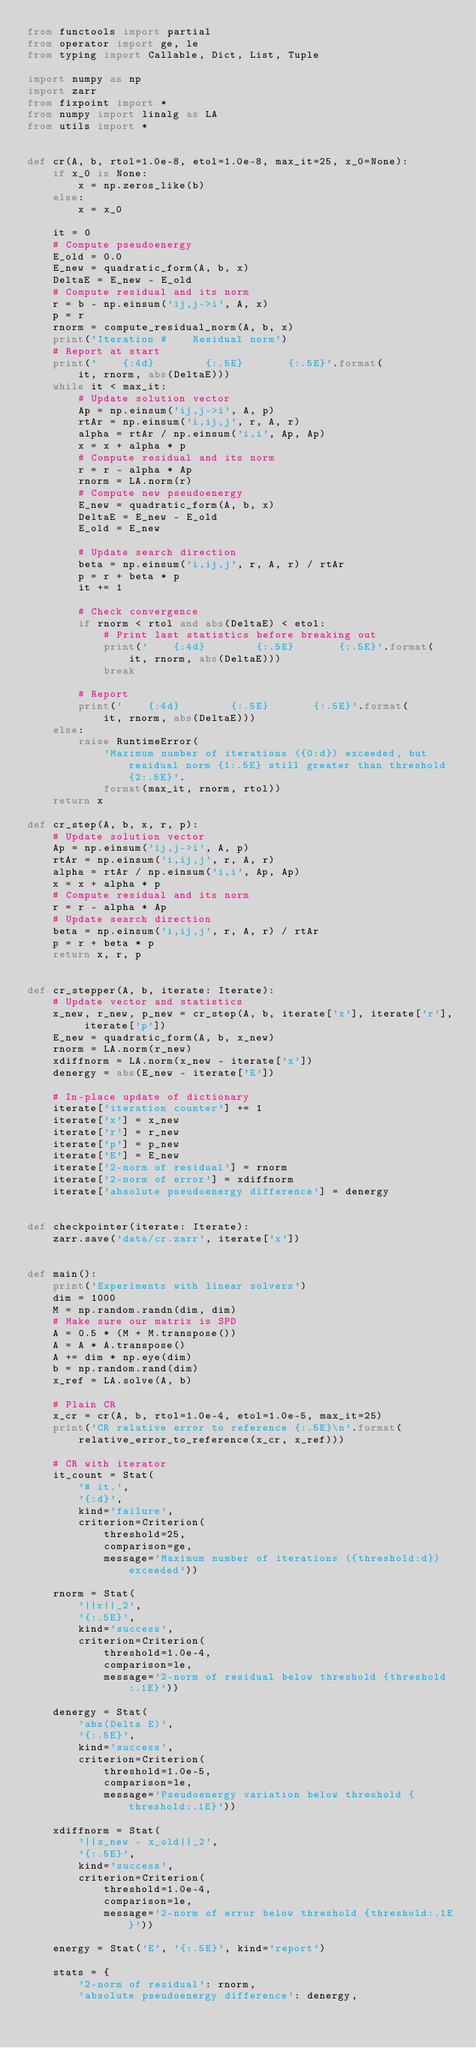<code> <loc_0><loc_0><loc_500><loc_500><_Python_>from functools import partial
from operator import ge, le
from typing import Callable, Dict, List, Tuple

import numpy as np
import zarr
from fixpoint import *
from numpy import linalg as LA
from utils import *


def cr(A, b, rtol=1.0e-8, etol=1.0e-8, max_it=25, x_0=None):
    if x_0 is None:
        x = np.zeros_like(b)
    else:
        x = x_0

    it = 0
    # Compute pseudoenergy
    E_old = 0.0
    E_new = quadratic_form(A, b, x)
    DeltaE = E_new - E_old
    # Compute residual and its norm
    r = b - np.einsum('ij,j->i', A, x)
    p = r
    rnorm = compute_residual_norm(A, b, x)
    print('Iteration #    Residual norm')
    # Report at start
    print('    {:4d}        {:.5E}       {:.5E}'.format(
        it, rnorm, abs(DeltaE)))
    while it < max_it:
        # Update solution vector
        Ap = np.einsum('ij,j->i', A, p)
        rtAr = np.einsum('i,ij,j', r, A, r)
        alpha = rtAr / np.einsum('i,i', Ap, Ap)
        x = x + alpha * p
        # Compute residual and its norm
        r = r - alpha * Ap
        rnorm = LA.norm(r)
        # Compute new pseudoenergy
        E_new = quadratic_form(A, b, x)
        DeltaE = E_new - E_old
        E_old = E_new

        # Update search direction
        beta = np.einsum('i,ij,j', r, A, r) / rtAr
        p = r + beta * p
        it += 1

        # Check convergence
        if rnorm < rtol and abs(DeltaE) < etol:
            # Print last statistics before breaking out
            print('    {:4d}        {:.5E}       {:.5E}'.format(
                it, rnorm, abs(DeltaE)))
            break

        # Report
        print('    {:4d}        {:.5E}       {:.5E}'.format(
            it, rnorm, abs(DeltaE)))
    else:
        raise RuntimeError(
            'Maximum number of iterations ({0:d}) exceeded, but residual norm {1:.5E} still greater than threshold {2:.5E}'.
            format(max_it, rnorm, rtol))
    return x

def cr_step(A, b, x, r, p):
    # Update solution vector
    Ap = np.einsum('ij,j->i', A, p)
    rtAr = np.einsum('i,ij,j', r, A, r)
    alpha = rtAr / np.einsum('i,i', Ap, Ap)
    x = x + alpha * p
    # Compute residual and its norm
    r = r - alpha * Ap
    # Update search direction
    beta = np.einsum('i,ij,j', r, A, r) / rtAr
    p = r + beta * p
    return x, r, p


def cr_stepper(A, b, iterate: Iterate):
    # Update vector and statistics
    x_new, r_new, p_new = cr_step(A, b, iterate['x'], iterate['r'], iterate['p'])
    E_new = quadratic_form(A, b, x_new)
    rnorm = LA.norm(r_new)
    xdiffnorm = LA.norm(x_new - iterate['x'])
    denergy = abs(E_new - iterate['E'])

    # In-place update of dictionary
    iterate['iteration counter'] += 1
    iterate['x'] = x_new
    iterate['r'] = r_new
    iterate['p'] = p_new
    iterate['E'] = E_new
    iterate['2-norm of residual'] = rnorm
    iterate['2-norm of error'] = xdiffnorm
    iterate['absolute pseudoenergy difference'] = denergy


def checkpointer(iterate: Iterate):
    zarr.save('data/cr.zarr', iterate['x'])


def main():
    print('Experiments with linear solvers')
    dim = 1000
    M = np.random.randn(dim, dim)
    # Make sure our matrix is SPD
    A = 0.5 * (M + M.transpose())
    A = A * A.transpose()
    A += dim * np.eye(dim)
    b = np.random.rand(dim)
    x_ref = LA.solve(A, b)

    # Plain CR
    x_cr = cr(A, b, rtol=1.0e-4, etol=1.0e-5, max_it=25)
    print('CR relative error to reference {:.5E}\n'.format(
        relative_error_to_reference(x_cr, x_ref)))

    # CR with iterator
    it_count = Stat(
        '# it.',
        '{:d}',
        kind='failure',
        criterion=Criterion(
            threshold=25,
            comparison=ge,
            message='Maximum number of iterations ({threshold:d}) exceeded'))

    rnorm = Stat(
        '||r||_2',
        '{:.5E}',
        kind='success',
        criterion=Criterion(
            threshold=1.0e-4,
            comparison=le,
            message='2-norm of residual below threshold {threshold:.1E}'))

    denergy = Stat(
        'abs(Delta E)',
        '{:.5E}',
        kind='success',
        criterion=Criterion(
            threshold=1.0e-5,
            comparison=le,
            message='Pseudoenergy variation below threshold {threshold:.1E}'))

    xdiffnorm = Stat(
        '||x_new - x_old||_2',
        '{:.5E}',
        kind='success',
        criterion=Criterion(
            threshold=1.0e-4,
            comparison=le,
            message='2-norm of error below threshold {threshold:.1E}'))

    energy = Stat('E', '{:.5E}', kind='report')

    stats = {
        '2-norm of residual': rnorm,
        'absolute pseudoenergy difference': denergy,</code> 